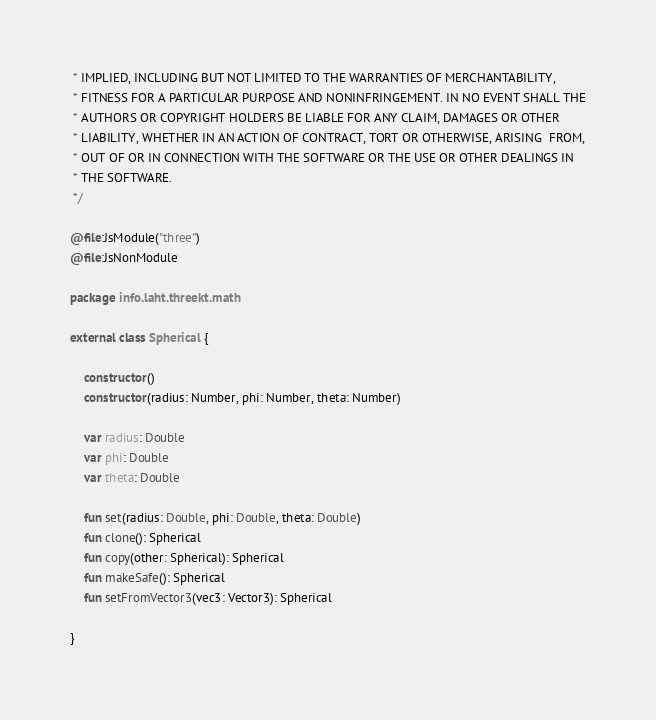Convert code to text. <code><loc_0><loc_0><loc_500><loc_500><_Kotlin_> * IMPLIED, INCLUDING BUT NOT LIMITED TO THE WARRANTIES OF MERCHANTABILITY,
 * FITNESS FOR A PARTICULAR PURPOSE AND NONINFRINGEMENT. IN NO EVENT SHALL THE
 * AUTHORS OR COPYRIGHT HOLDERS BE LIABLE FOR ANY CLAIM, DAMAGES OR OTHER
 * LIABILITY, WHETHER IN AN ACTION OF CONTRACT, TORT OR OTHERWISE, ARISING  FROM,
 * OUT OF OR IN CONNECTION WITH THE SOFTWARE OR THE USE OR OTHER DEALINGS IN
 * THE SOFTWARE.
 */

@file:JsModule("three")
@file:JsNonModule

package info.laht.threekt.math

external class Spherical {

    constructor()
    constructor(radius: Number, phi: Number, theta: Number)

    var radius: Double
    var phi: Double
    var theta: Double

    fun set(radius: Double, phi: Double, theta: Double)
    fun clone(): Spherical
    fun copy(other: Spherical): Spherical
    fun makeSafe(): Spherical
    fun setFromVector3(vec3: Vector3): Spherical

}</code> 